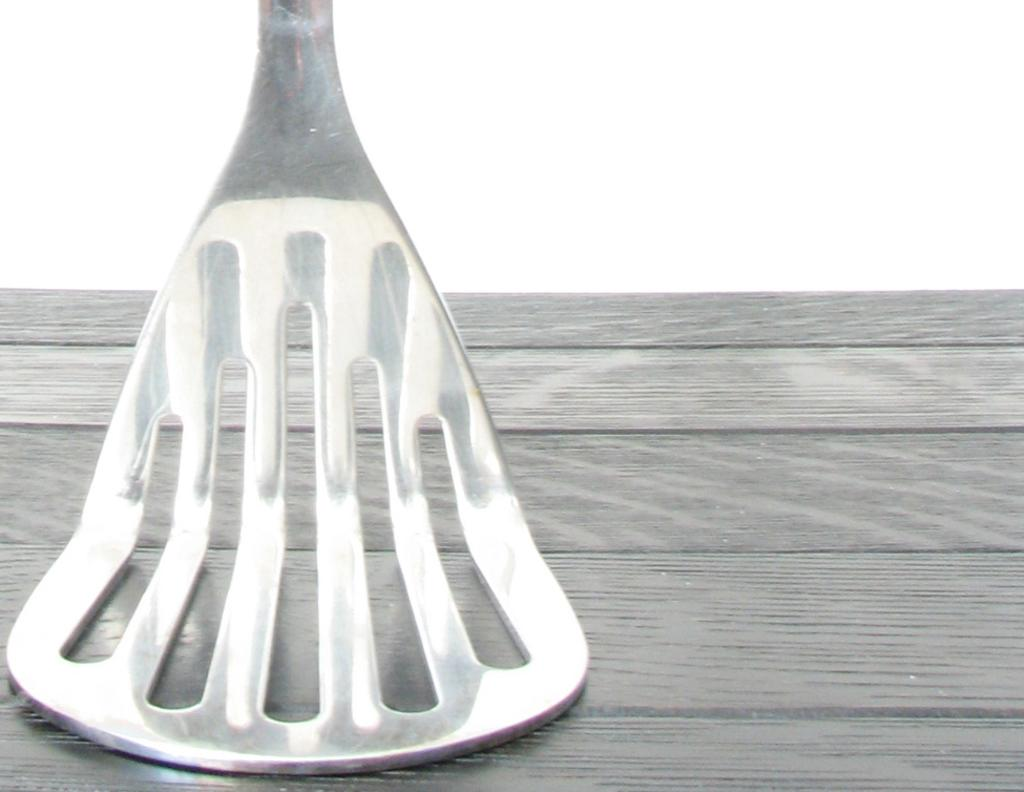What type of object is in the image? There is a metal object in the image. What is the purpose of the metal object? The metal object resembles a kitchen utensil. On what surface is the metal object placed? The metal object is placed on a wooden surface. What color is the background of the image? The background of the image is white. How does the mailbox contribute to the loss of the coach in the image? There is no mailbox, loss, or coach present in the image. 